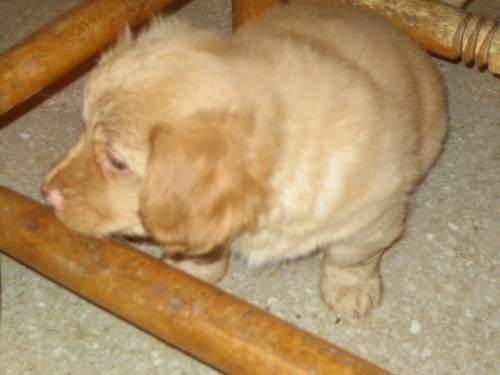What might be the breed or characteristics of the dog in the picture? While it's often challenging to determine breed with certainty from a single image, the puppy appears to resemble a retriever with its fluffy coat and the broad shape of its face. Retrievers are known for their dense, water-repellent fur and kind, friendly eyes, traits that seem to be reflected in this young pup. 